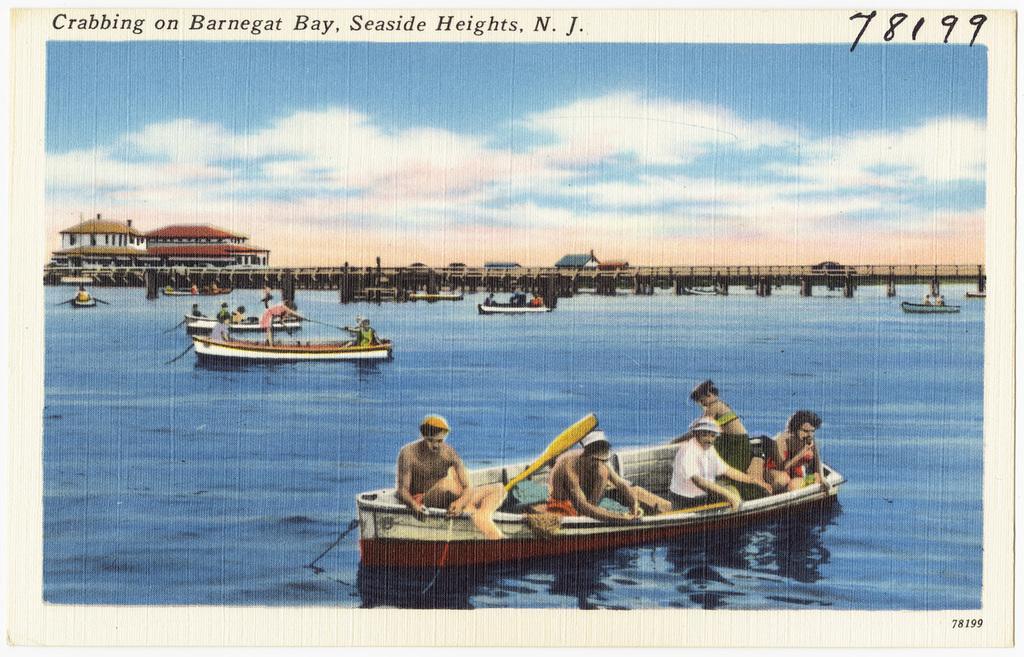Can you describe this image briefly? This is a printed picture of we see few boats in the water and a bridge and few houses and a blue cloudy sky and we see text on the top of the picture and numbers on the right corner. 